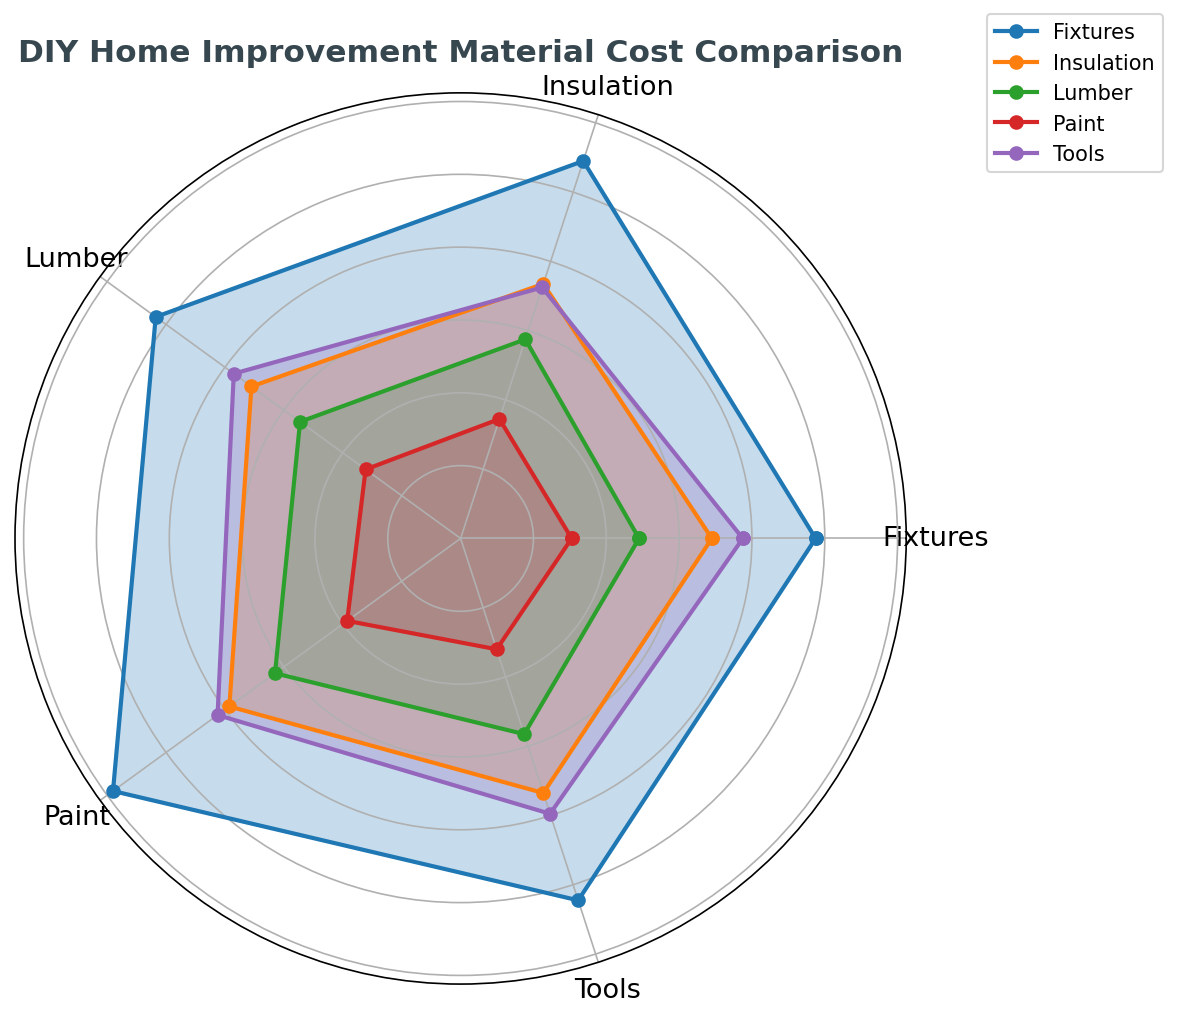Which material has the highest average cost across all stores? To determine the highest average cost, we need to look at each material's plot values on the radar chart and identify the one with the greatest overall length from the center. Fixtures have the visually longest plot line, indicating the highest cost.
Answer: Fixtures Which retailer offers the lowest average price for paint? To find this, examine the radar chart for the paint data points. Compare the lengths of the paint data lines for each retailer. The shortest paint data line corresponds to Local Supplier.
Answer: Local Supplier What’s the average cost of insulation across all retailers? From the plot, take the insulation points for each retailer (7, 7.5, 7.2, 7.8, 7.4). Compute their mean: (7 + 7.5 + 7.2 + 7.8 + 7.4) / 5 = 7.38.
Answer: 7.38 Among the given stores and online retailers, which two have the closest average cost for tools? Look at the tools' points for all data lines. Home Improvement Store 2 and Local Supplier have nearly the same lengths of radar lines for tools.
Answer: Home Improvement Store 2, Local Supplier If you were to exclude the highest priced store for each material, which material's average cost decreases the most? Identify the highest priced store for each material and compute the new average without that data point. Calculate the difference from the original average and compare these decreases. Insulation's cost will decrease the most.
Answer: Insulation Do any of the materials show consistent pricing across all stores? For consistent pricing, data lines for the material should be nearly identical in length across all aspects. Paint shows the least variation in the data lines on the radar chart.
Answer: Paint Which materials have an average cost higher than $8.5? Sum up the values for each retailer for each material and compute their averages. Any material average over $8.5 should be indicated. Tools and Fixtures both exceed this threshold.
Answer: Tools, Fixtures What’s the cost range for lumber among the different sellers? To find the range for lumber, identify the lowest and highest values for it from the chart and subtract the smallest from the largest value. The range for lumber is (6.6 – 4.8) = 1.8.
Answer: 1.8 How does the average cost for fixtures compare to the average cost for tools? Compute the average for fixtures (10 + 11 + 10.5 + 12 + 10.8 = 54.3 / 5 = 10.86) then for tools (8 + 7.5 + 7.8 + 8.2 + 7.9 = 39.4 / 5 = 7.88). Compare 10.86 to 7.88. Fixtures cost more on average.
Answer: Fixtures cost more What is the total cost if buying one unit of each material from the cheapest seller for each material? Identify the cheapest cost for each material and add them up: (Lumber 4.8 + Paint 3 + Tools 7 + Fixtures 9.5 + Insulation 6.8) = 31.1.
Answer: 31.1 